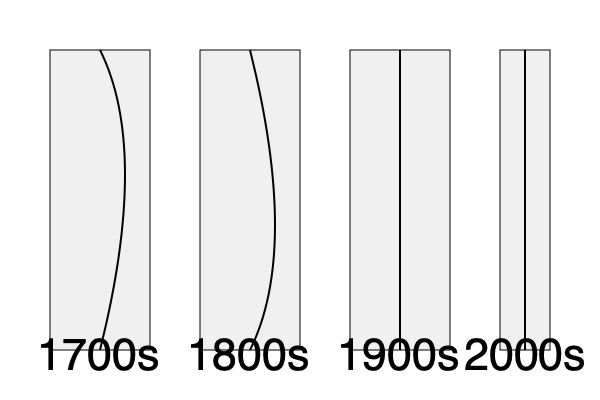Analyze the silhouette evolution depicted in the image. Which century's silhouette shows the most dramatic contrast between the upper and lower body, creating an exaggerated hourglass shape? To answer this question, we need to examine the silhouettes shown for each century:

1. 1700s: The silhouette shows a wide, bell-shaped lower body with a narrow waist, expanding again slightly at the chest. This creates a distinct hourglass shape, but with more emphasis on the lower body.

2. 1800s: This silhouette displays a more pronounced curve at the back, likely representing bustles or crinolines. The waist is narrow, and the upper body has some volume, creating a more balanced hourglass shape.

3. 1900s: The silhouette here is relatively straight, showing the shift towards more streamlined designs in the 20th century. There is little contrast between the upper and lower body.

4. 2000s: This silhouette is also quite straight, reflecting modern, less structured clothing styles.

Among these, the 1700s silhouette shows the most dramatic contrast between the upper and lower body. The extremely wide skirt paired with the narrow waist creates an exaggerated hourglass shape that is more pronounced than in any other century represented.

While the 1800s also shows an hourglass shape, it's more balanced and less extreme than the 1700s. The 1900s and 2000s show much straighter silhouettes with less defined waists, moving away from the dramatic hourglass shape.
Answer: 1700s 